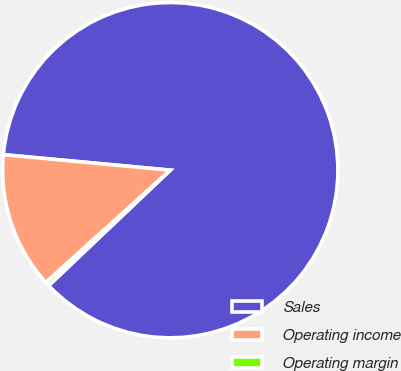<chart> <loc_0><loc_0><loc_500><loc_500><pie_chart><fcel>Sales<fcel>Operating income<fcel>Operating margin<nl><fcel>86.45%<fcel>13.17%<fcel>0.39%<nl></chart> 